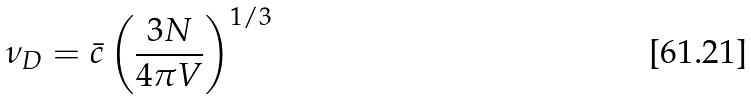<formula> <loc_0><loc_0><loc_500><loc_500>\nu _ { D } = \bar { c } \left ( \frac { 3 N } { 4 \pi V } \right ) ^ { 1 / 3 }</formula> 